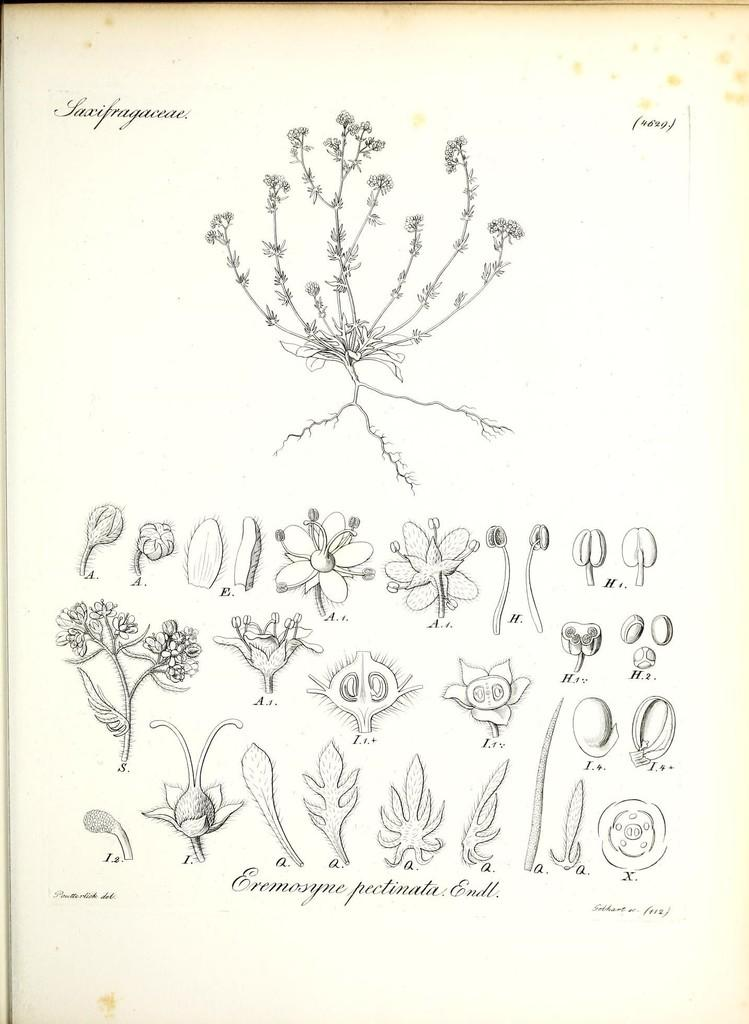What is featured on the poster in the image? The poster contains flowers, leaves, and plants. What else can be seen on the poster besides the plants? There is text written on the poster. What is the price of the dock shown in the image? There is no dock present in the image, so it is not possible to determine its price. 